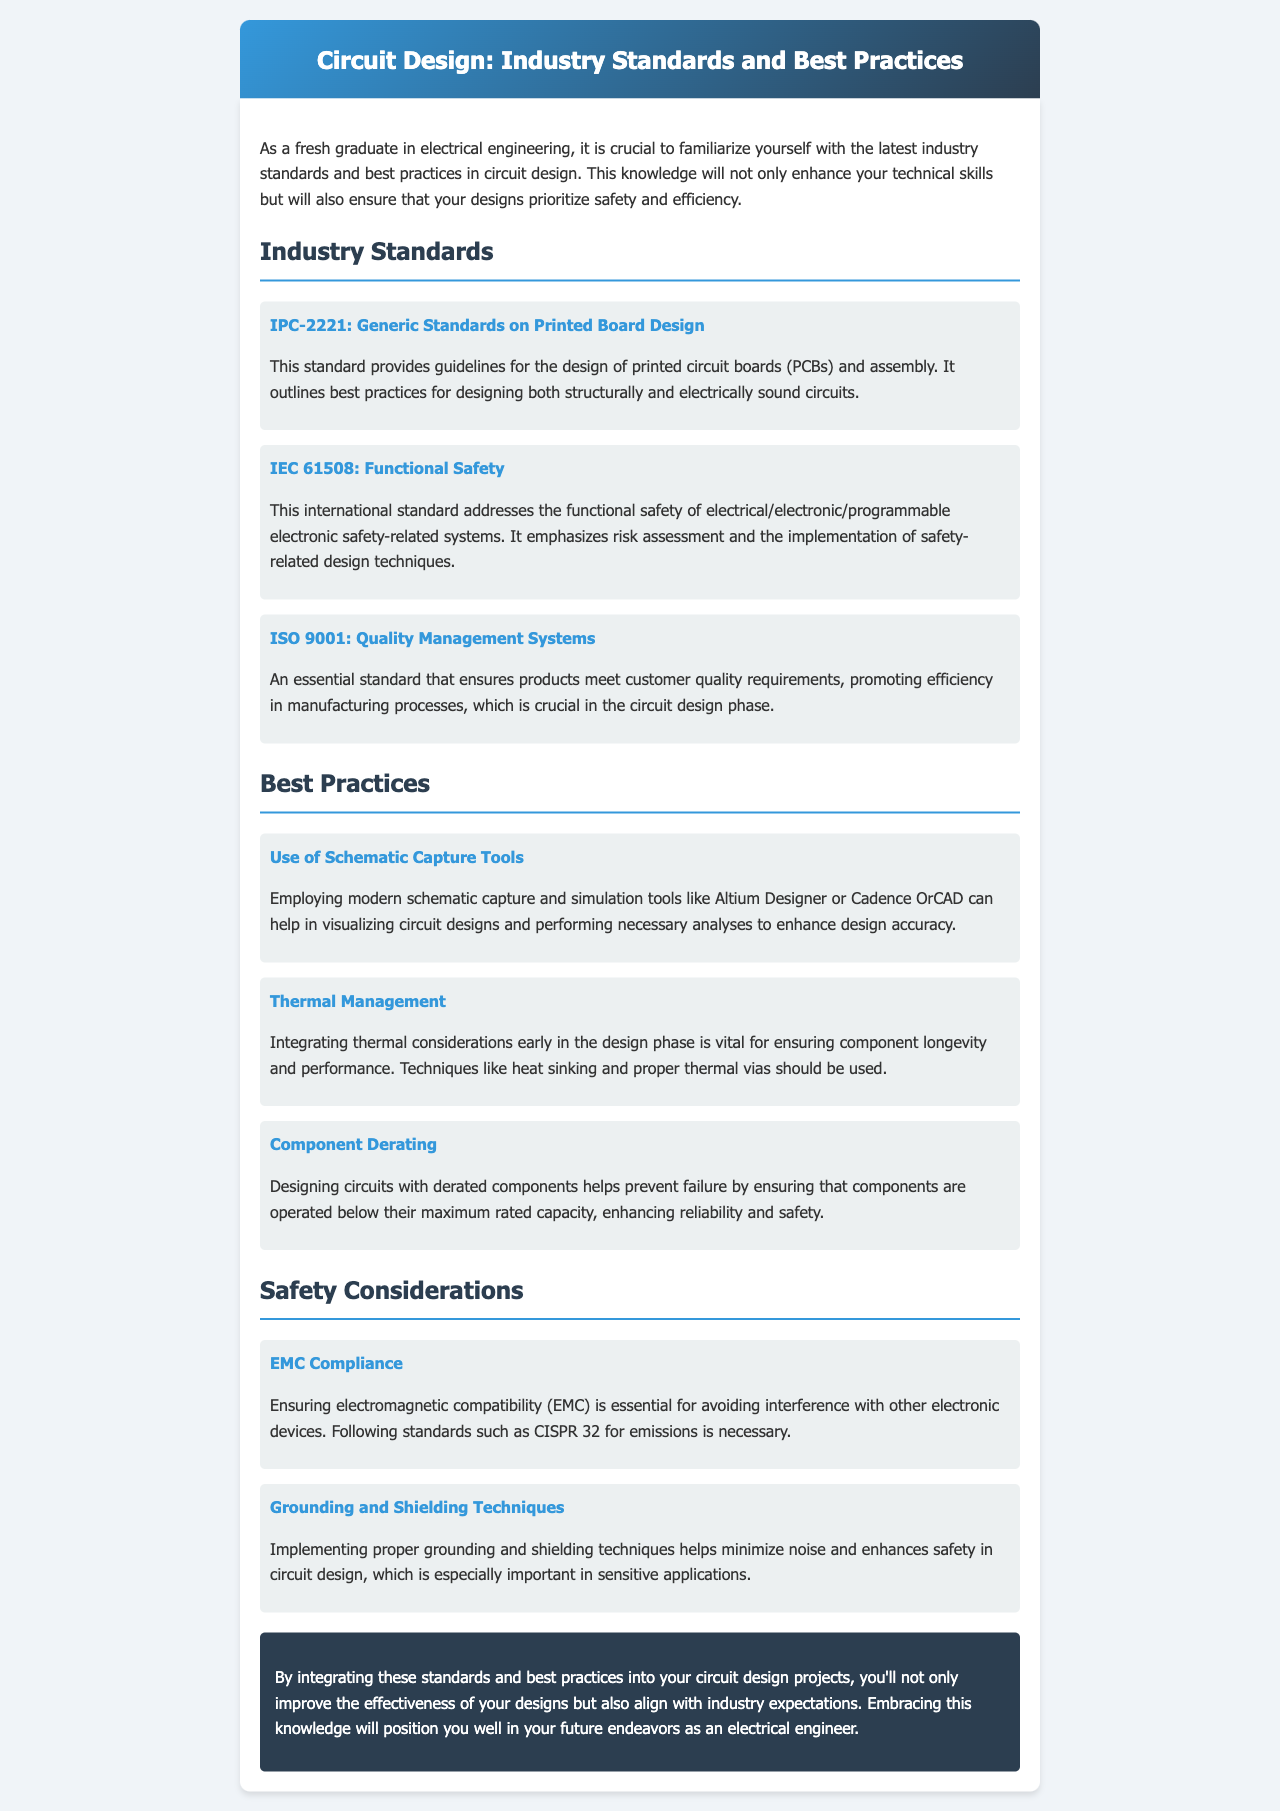What is IPC-2221? IPC-2221 is a standard that provides guidelines for the design of printed circuit boards (PCBs) and assembly.
Answer: Generic Standards on Printed Board Design What does IEC 61508 focus on? IEC 61508 focuses on the functional safety of electrical/electronic/programmable electronic safety-related systems.
Answer: Functional Safety What is the purpose of ISO 9001? ISO 9001 ensures products meet customer quality requirements and promotes efficiency in manufacturing processes.
Answer: Quality Management Systems What is one tool recommended for schematic capture? Altium Designer is recommended as a schematic capture tool.
Answer: Altium Designer What is an important practice during thermal management? Techniques like heat sinking and proper thermal vias should be used for thermal management.
Answer: Heat sinking Which standard ensures electromagnetic compatibility? CISPR 32 ensures electromagnetic compatibility.
Answer: CISPR 32 What safety technique minimizes noise in circuit design? Grounding and shielding techniques help minimize noise.
Answer: Grounding and Shielding Techniques What is component derating intended to prevent? Component derating is intended to prevent failure by operating components below their maximum rated capacity.
Answer: Failure prevention How can integrating industry standards affect your designs? Integrating industry standards improves the effectiveness of your designs and aligns with industry expectations.
Answer: Improves effectiveness 